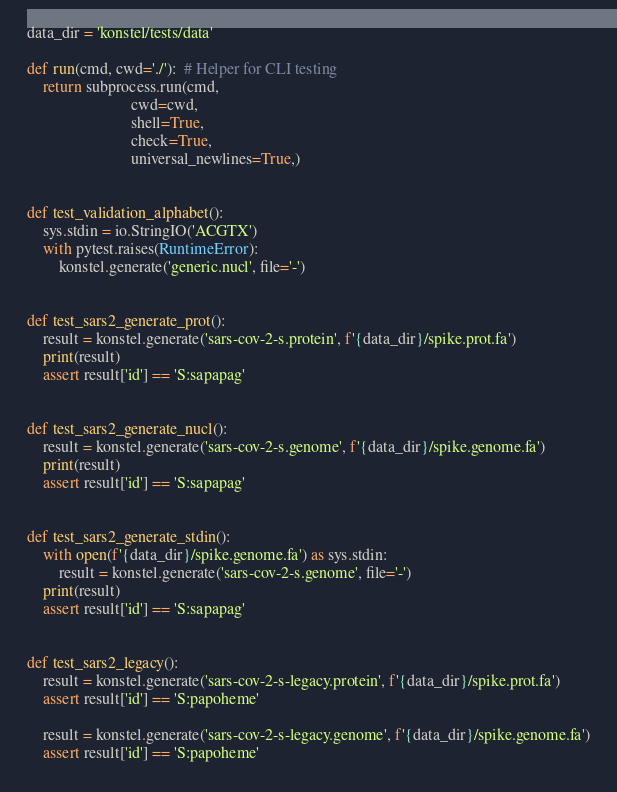Convert code to text. <code><loc_0><loc_0><loc_500><loc_500><_Python_>
data_dir = 'konstel/tests/data'

def run(cmd, cwd='./'):  # Helper for CLI testing
    return subprocess.run(cmd,
                          cwd=cwd,
                          shell=True,
                          check=True,
                          universal_newlines=True,)


def test_validation_alphabet():
    sys.stdin = io.StringIO('ACGTX')
    with pytest.raises(RuntimeError):
        konstel.generate('generic.nucl', file='-')


def test_sars2_generate_prot():
    result = konstel.generate('sars-cov-2-s.protein', f'{data_dir}/spike.prot.fa')
    print(result)
    assert result['id'] == 'S:sapapag'


def test_sars2_generate_nucl():
    result = konstel.generate('sars-cov-2-s.genome', f'{data_dir}/spike.genome.fa')
    print(result)
    assert result['id'] == 'S:sapapag'


def test_sars2_generate_stdin():
    with open(f'{data_dir}/spike.genome.fa') as sys.stdin:
        result = konstel.generate('sars-cov-2-s.genome', file='-')
    print(result)
    assert result['id'] == 'S:sapapag'


def test_sars2_legacy():
    result = konstel.generate('sars-cov-2-s-legacy.protein', f'{data_dir}/spike.prot.fa')
    assert result['id'] == 'S:papoheme'

    result = konstel.generate('sars-cov-2-s-legacy.genome', f'{data_dir}/spike.genome.fa')
    assert result['id'] == 'S:papoheme'</code> 